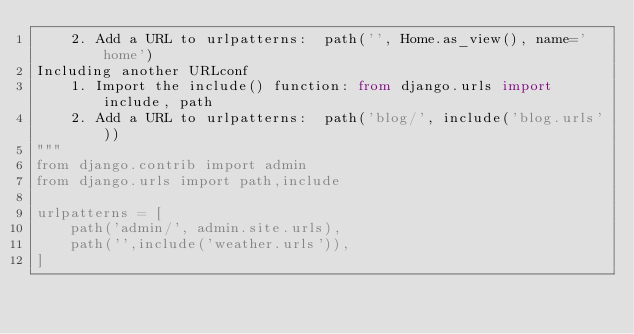<code> <loc_0><loc_0><loc_500><loc_500><_Python_>    2. Add a URL to urlpatterns:  path('', Home.as_view(), name='home')
Including another URLconf
    1. Import the include() function: from django.urls import include, path
    2. Add a URL to urlpatterns:  path('blog/', include('blog.urls'))
"""
from django.contrib import admin
from django.urls import path,include

urlpatterns = [
    path('admin/', admin.site.urls),
    path('',include('weather.urls')),
]
</code> 